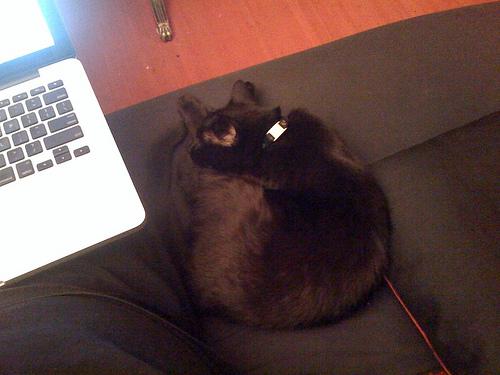Is the computer being used?
Write a very short answer. No. Which cat is on top?
Give a very brief answer. Black. Is there a dog there?
Write a very short answer. No. Is this an efficient desk area?
Answer briefly. No. What type of animal is shown?
Give a very brief answer. Cat. Is the cat wearing a collar?
Concise answer only. Yes. 